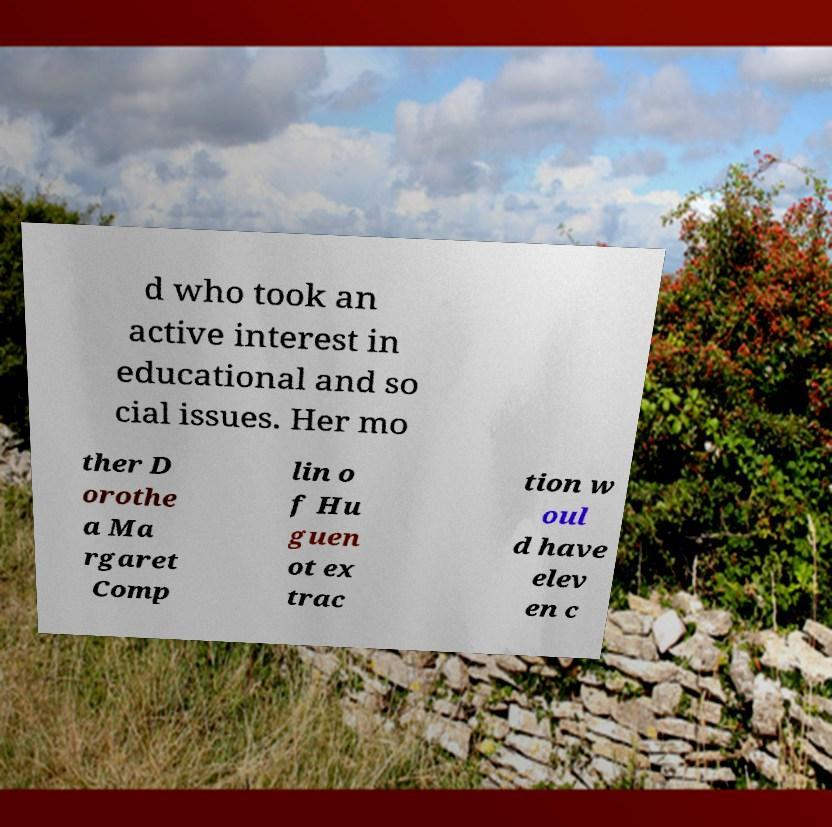I need the written content from this picture converted into text. Can you do that? d who took an active interest in educational and so cial issues. Her mo ther D orothe a Ma rgaret Comp lin o f Hu guen ot ex trac tion w oul d have elev en c 